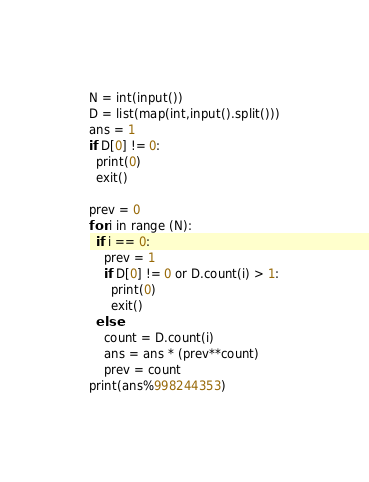Convert code to text. <code><loc_0><loc_0><loc_500><loc_500><_Python_>N = int(input())
D = list(map(int,input().split()))
ans = 1
if D[0] != 0:
  print(0)
  exit()

prev = 0
for i in range (N):
  if i == 0:
    prev = 1
    if D[0] != 0 or D.count(i) > 1:
      print(0)
      exit()
  else:
    count = D.count(i)
    ans = ans * (prev**count)
    prev = count
print(ans%998244353)</code> 